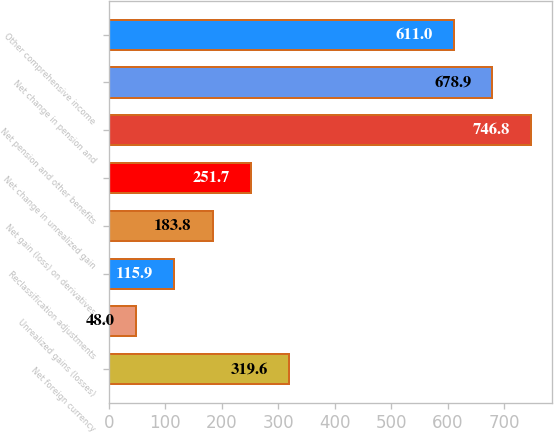<chart> <loc_0><loc_0><loc_500><loc_500><bar_chart><fcel>Net foreign currency<fcel>Unrealized gains (losses)<fcel>Reclassification adjustments<fcel>Net gain (loss) on derivatives<fcel>Net change in unrealized gain<fcel>Net pension and other benefits<fcel>Net change in pension and<fcel>Other comprehensive income<nl><fcel>319.6<fcel>48<fcel>115.9<fcel>183.8<fcel>251.7<fcel>746.8<fcel>678.9<fcel>611<nl></chart> 